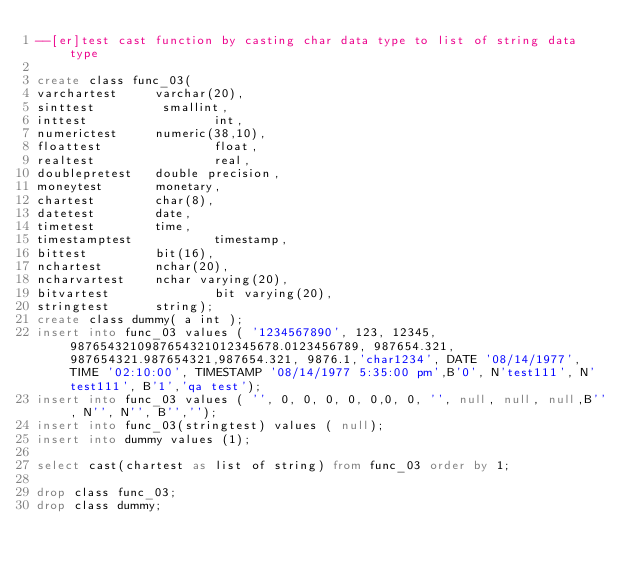Convert code to text. <code><loc_0><loc_0><loc_500><loc_500><_SQL_>--[er]test cast function by casting char data type to list of string data type

create class func_03(
varchartest     varchar(20),
sinttest         smallint,
inttest                 int,
numerictest     numeric(38,10),
floattest               float,
realtest                real,
doublepretest   double precision,
moneytest       monetary,
chartest        char(8),
datetest        date,
timetest        time,
timestamptest           timestamp,
bittest         bit(16),
nchartest       nchar(20),
ncharvartest    nchar varying(20),
bitvartest              bit varying(20),
stringtest      string);
create class dummy( a int );
insert into func_03 values ( '1234567890', 123, 12345, 9876543210987654321012345678.0123456789, 987654.321, 987654321.987654321,987654.321, 9876.1,'char1234', DATE '08/14/1977', TIME '02:10:00', TIMESTAMP '08/14/1977 5:35:00 pm',B'0', N'test111', N'test111', B'1','qa test');
insert into func_03 values ( '', 0, 0, 0, 0, 0,0, 0, '', null, null, null,B'', N'', N'', B'','');
insert into func_03(stringtest) values ( null);
insert into dummy values (1);

select cast(chartest as list of string) from func_03 order by 1;

drop class func_03;
drop class dummy;
</code> 